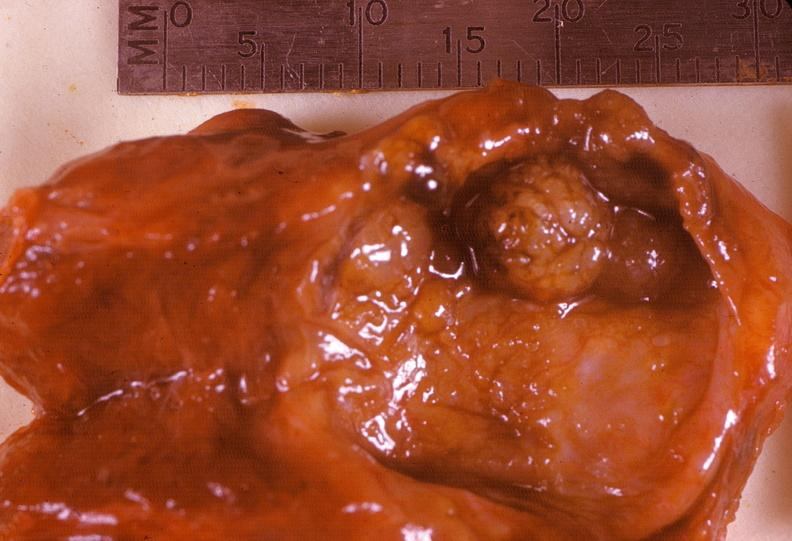what is present?
Answer the question using a single word or phrase. Endocrine 